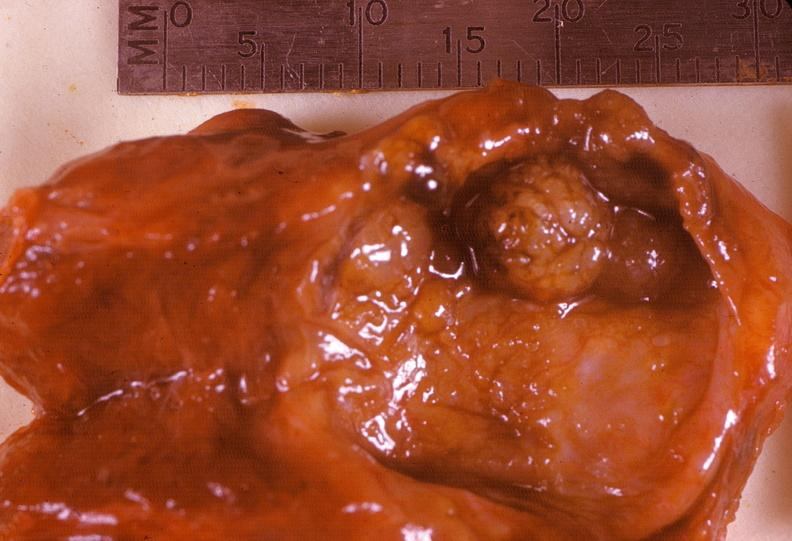what is present?
Answer the question using a single word or phrase. Endocrine 